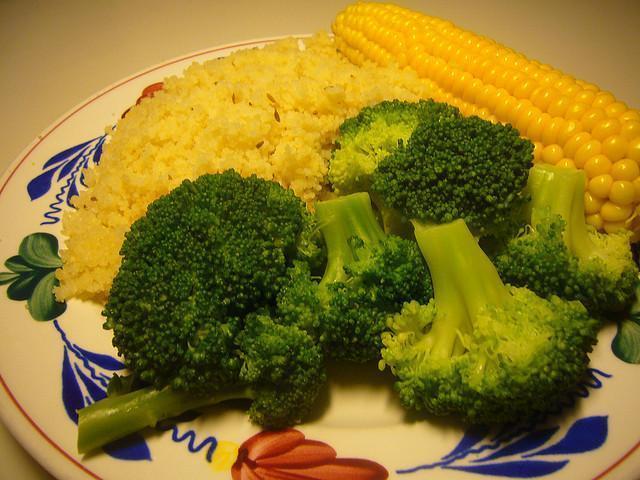How many broccolis are in the picture?
Give a very brief answer. 5. 